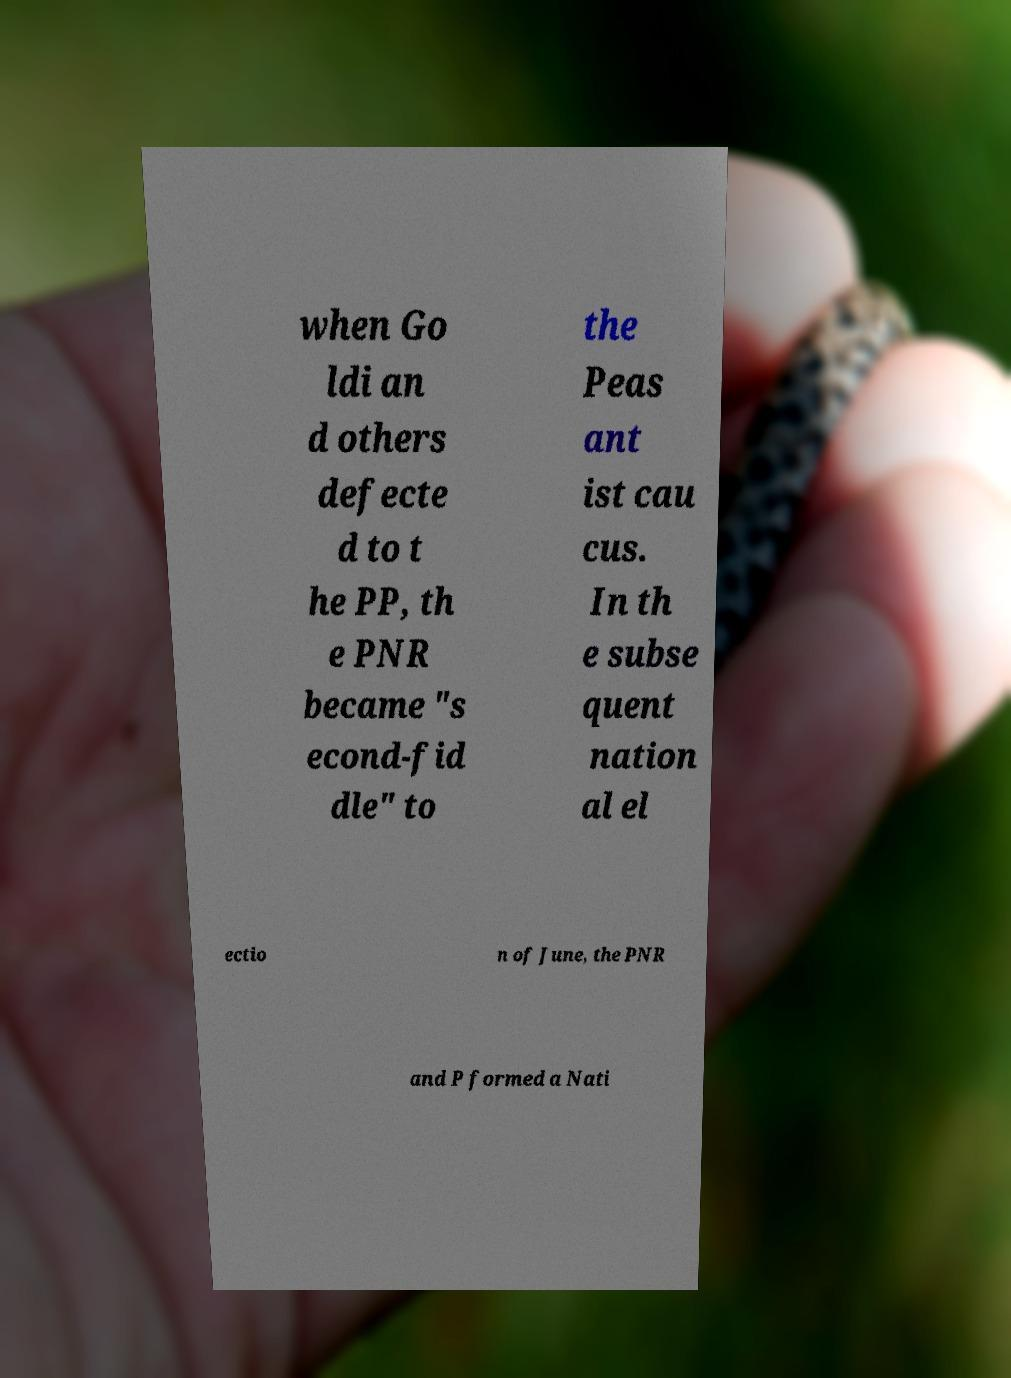Could you assist in decoding the text presented in this image and type it out clearly? when Go ldi an d others defecte d to t he PP, th e PNR became "s econd-fid dle" to the Peas ant ist cau cus. In th e subse quent nation al el ectio n of June, the PNR and P formed a Nati 